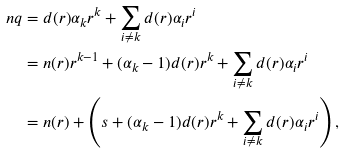<formula> <loc_0><loc_0><loc_500><loc_500>n q & = d ( r ) \alpha _ { k } r ^ { k } + \sum _ { i \neq k } d ( r ) \alpha _ { i } r ^ { i } \\ & = n ( r ) r ^ { k - 1 } + ( \alpha _ { k } - 1 ) d ( r ) r ^ { k } + \sum _ { i \neq k } d ( r ) \alpha _ { i } r ^ { i } \\ & = n ( r ) + \left ( s + ( \alpha _ { k } - 1 ) d ( r ) r ^ { k } + \sum _ { i \neq k } d ( r ) \alpha _ { i } r ^ { i } \right ) ,</formula> 